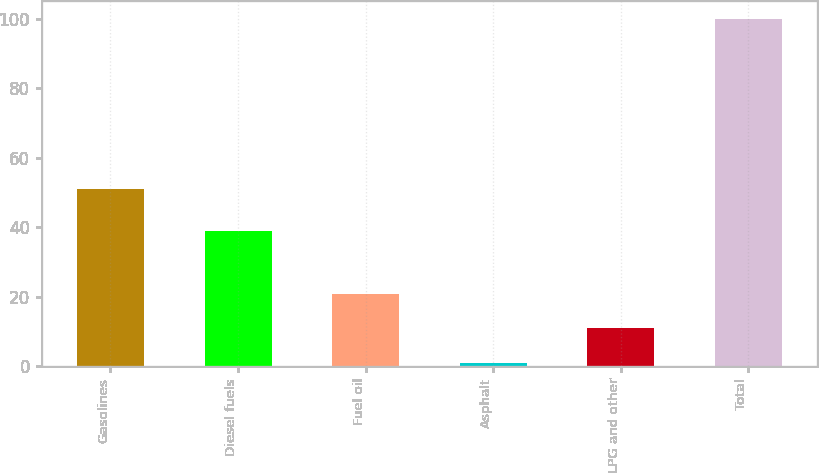Convert chart to OTSL. <chart><loc_0><loc_0><loc_500><loc_500><bar_chart><fcel>Gasolines<fcel>Diesel fuels<fcel>Fuel oil<fcel>Asphalt<fcel>LPG and other<fcel>Total<nl><fcel>51<fcel>39<fcel>20.8<fcel>1<fcel>10.9<fcel>100<nl></chart> 